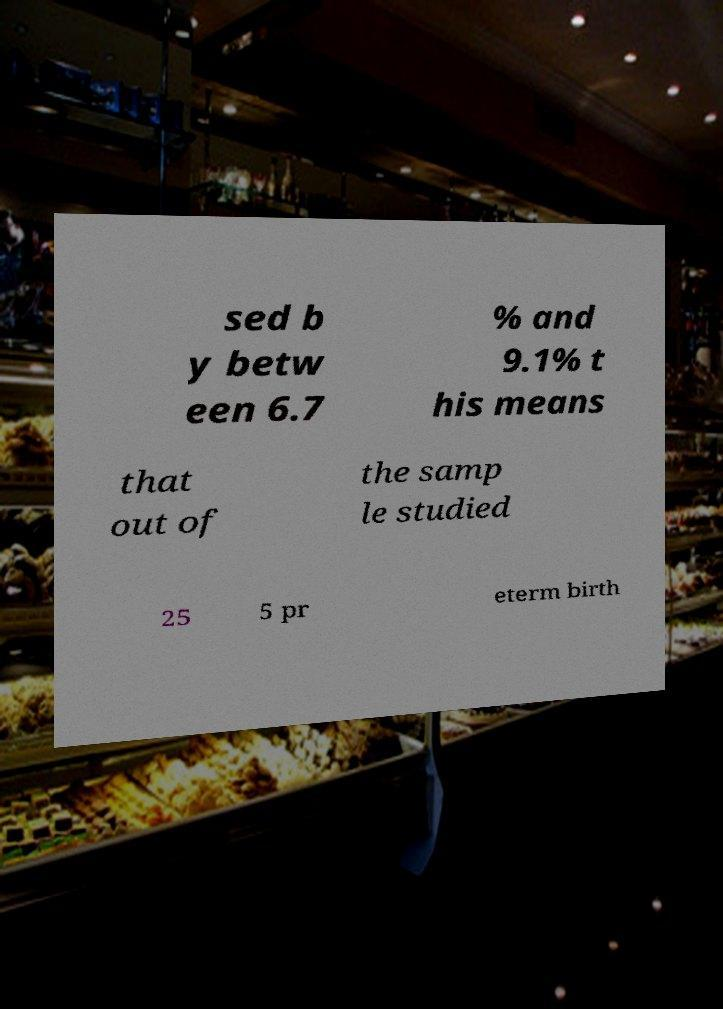Please read and relay the text visible in this image. What does it say? sed b y betw een 6.7 % and 9.1% t his means that out of the samp le studied 25 5 pr eterm birth 